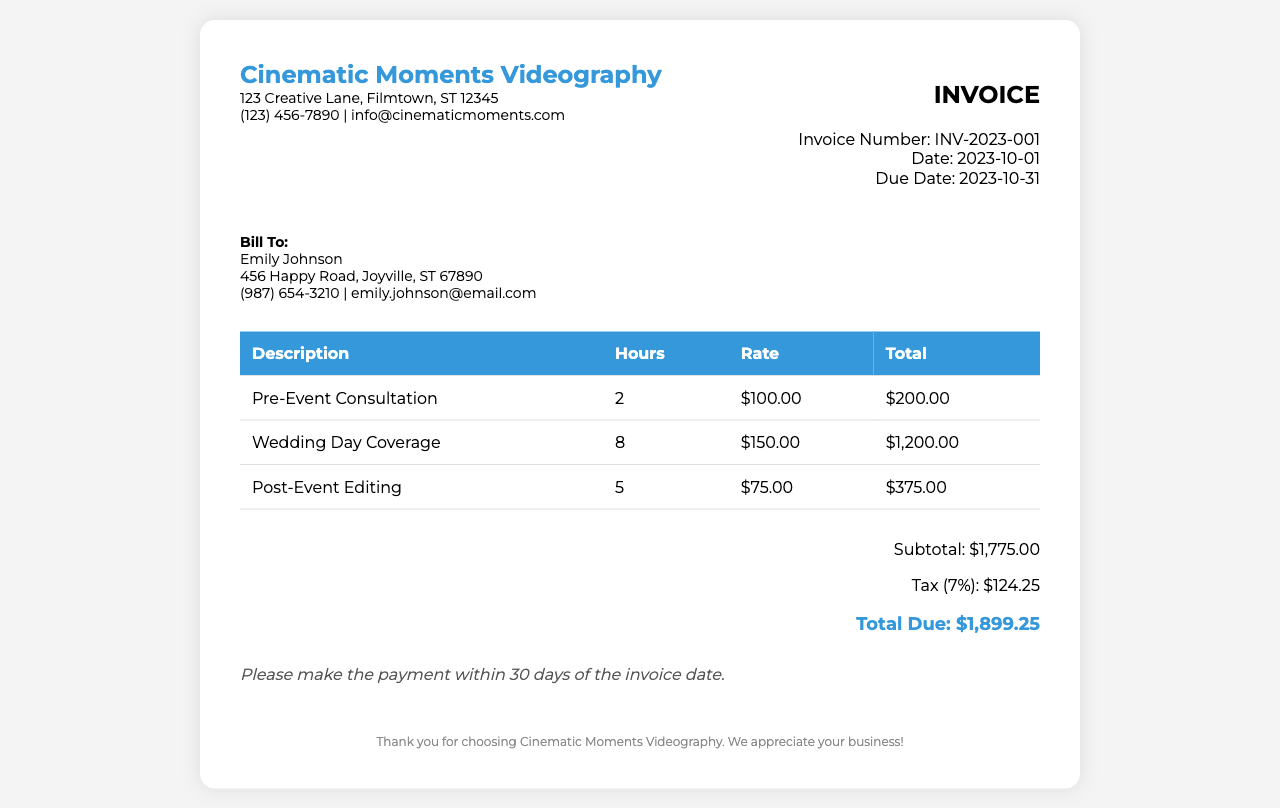What is the invoice number? The invoice number is stated below the invoice title as INV-2023-001.
Answer: INV-2023-001 Who is the client? The client is specified in the "Bill To" section as Emily Johnson.
Answer: Emily Johnson What is the total due amount? The total due amount is listed in the summary section as $1,899.25.
Answer: $1,899.25 How many hours were billed for the Wedding Day Coverage? The number of hours for Wedding Day Coverage is detailed in the table as 8 hours.
Answer: 8 What percentage is the tax applied? The tax percentage applied is specified in the summary section as 7%.
Answer: 7% What is the rate for Post-Event Editing? The rate for Post-Event Editing is mentioned in the table as $75.00.
Answer: $75.00 How many hours were dedicated to the Pre-Event Consultation? The hours for Pre-Event Consultation are detailed in the table as 2 hours.
Answer: 2 When is the due date for payment? The due date for payment is provided in the invoice details as 2023-10-31.
Answer: 2023-10-31 What is the subtotal amount listed in the invoice? The subtotal amount is noted in the summary section as $1,775.00.
Answer: $1,775.00 